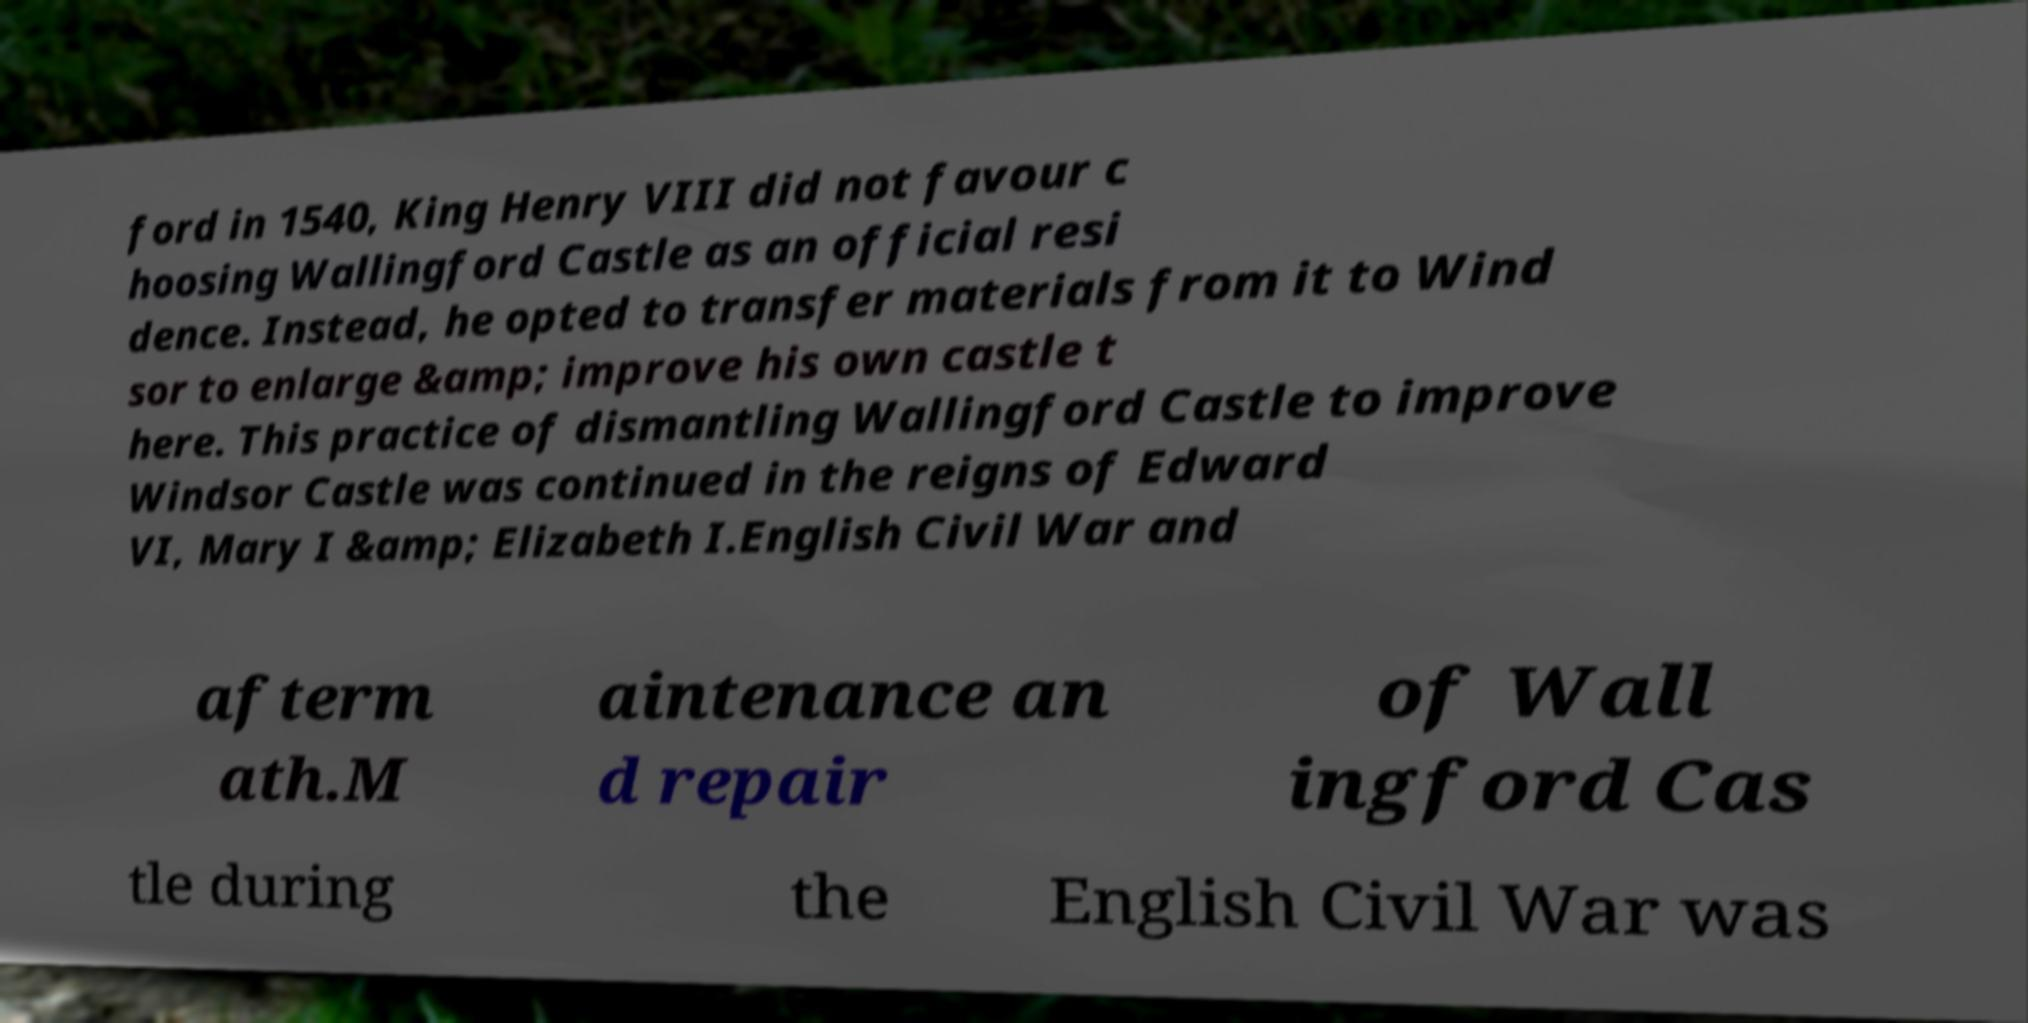For documentation purposes, I need the text within this image transcribed. Could you provide that? ford in 1540, King Henry VIII did not favour c hoosing Wallingford Castle as an official resi dence. Instead, he opted to transfer materials from it to Wind sor to enlarge &amp; improve his own castle t here. This practice of dismantling Wallingford Castle to improve Windsor Castle was continued in the reigns of Edward VI, Mary I &amp; Elizabeth I.English Civil War and afterm ath.M aintenance an d repair of Wall ingford Cas tle during the English Civil War was 